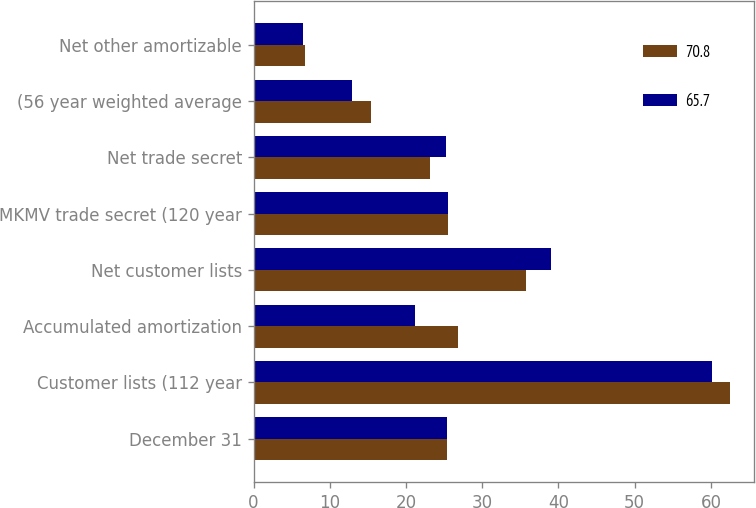Convert chart. <chart><loc_0><loc_0><loc_500><loc_500><stacked_bar_chart><ecel><fcel>December 31<fcel>Customer lists (112 year<fcel>Accumulated amortization<fcel>Net customer lists<fcel>MKMV trade secret (120 year<fcel>Net trade secret<fcel>(56 year weighted average<fcel>Net other amortizable<nl><fcel>70.8<fcel>25.4<fcel>62.5<fcel>26.8<fcel>35.7<fcel>25.5<fcel>23.2<fcel>15.4<fcel>6.8<nl><fcel>65.7<fcel>25.4<fcel>60.2<fcel>21.2<fcel>39<fcel>25.5<fcel>25.3<fcel>12.9<fcel>6.5<nl></chart> 